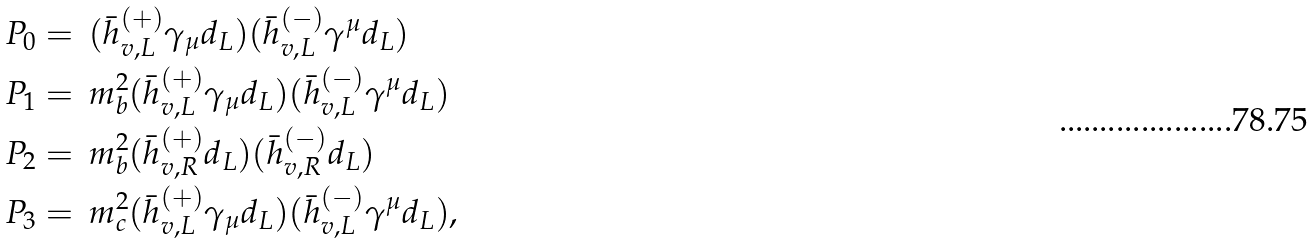Convert formula to latex. <formula><loc_0><loc_0><loc_500><loc_500>P _ { 0 } & = \, ( \bar { h } _ { v , L } ^ { ( + ) } \gamma _ { \mu } d _ { L } ) ( \bar { h } _ { v , L } ^ { ( - ) } \gamma ^ { \mu } d _ { L } ) \\ P _ { 1 } & = \, m _ { b } ^ { 2 } ( \bar { h } _ { v , L } ^ { ( + ) } \gamma _ { \mu } d _ { L } ) ( \bar { h } _ { v , L } ^ { ( - ) } \gamma ^ { \mu } d _ { L } ) \\ P _ { 2 } & = \, m _ { b } ^ { 2 } ( \bar { h } _ { v , R } ^ { ( + ) } d _ { L } ) ( \bar { h } _ { v , R } ^ { ( - ) } d _ { L } ) \\ P _ { 3 } & = \, m _ { c } ^ { 2 } ( \bar { h } _ { v , L } ^ { ( + ) } \gamma _ { \mu } d _ { L } ) ( \bar { h } _ { v , L } ^ { ( - ) } \gamma ^ { \mu } d _ { L } ) ,</formula> 